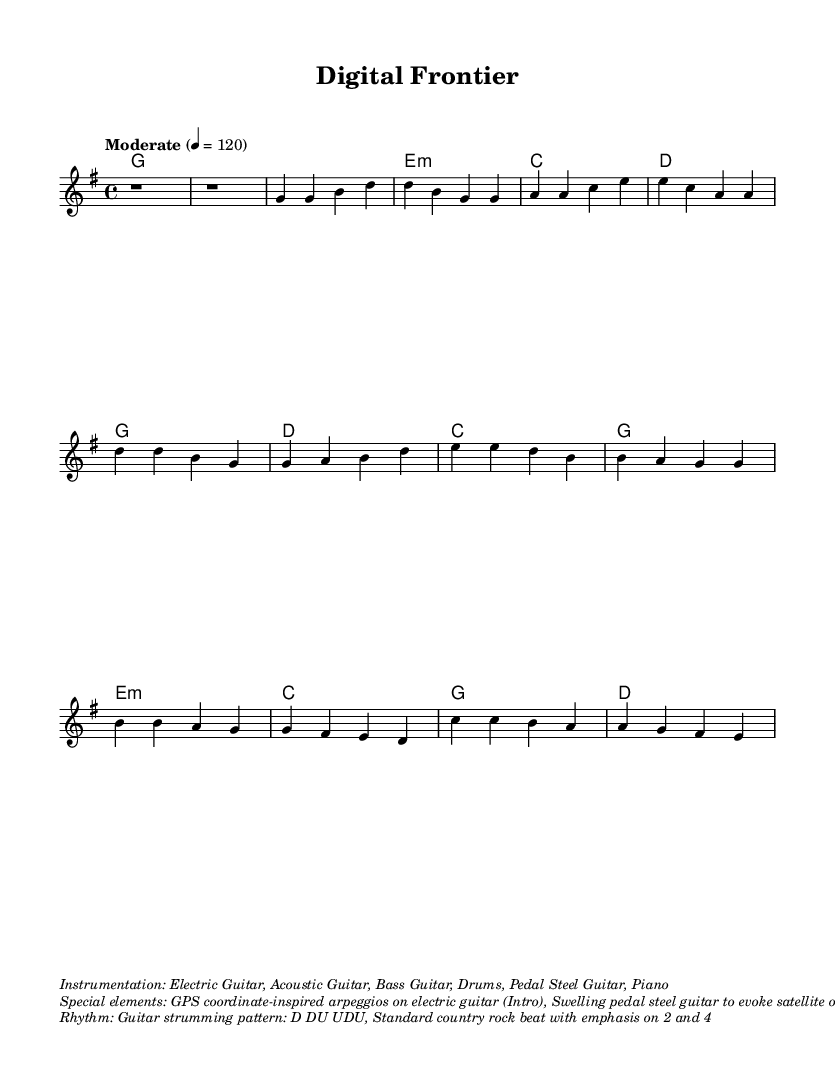What is the key signature of this music? The key signature is G major, which has one sharp (F#). This can be determined by looking at the key signature section indicated at the beginning of the score.
Answer: G major What is the time signature of this music? The time signature is 4/4, which means there are four beats in each measure and the quarter note gets one beat. This is indicated at the beginning of the score near the key signature.
Answer: 4/4 What is the tempo marking for this piece? The tempo marking is "Moderate," with a specific tempo of 120 beats per minute. The tempo is typically written above the staff at the start of the score.
Answer: Moderate 4 = 120 What is the main instrument used for the lead melody? The main instrument used for the lead melody is the Electric Guitar, as indicated in the instrumentation section of the score.
Answer: Electric Guitar Which special musical element is used in the bridge section? The special musical element in the bridge is the swelling pedal steel guitar to evoke satellite orbits. This is mentioned in the special elements area of the score.
Answer: Swelling pedal steel guitar What rhythmic pattern is used for guitar strumming? The rhythmic pattern for guitar strumming is D DU UDU, which is typically written in the markup section describing rhythm.
Answer: D DU UDU 